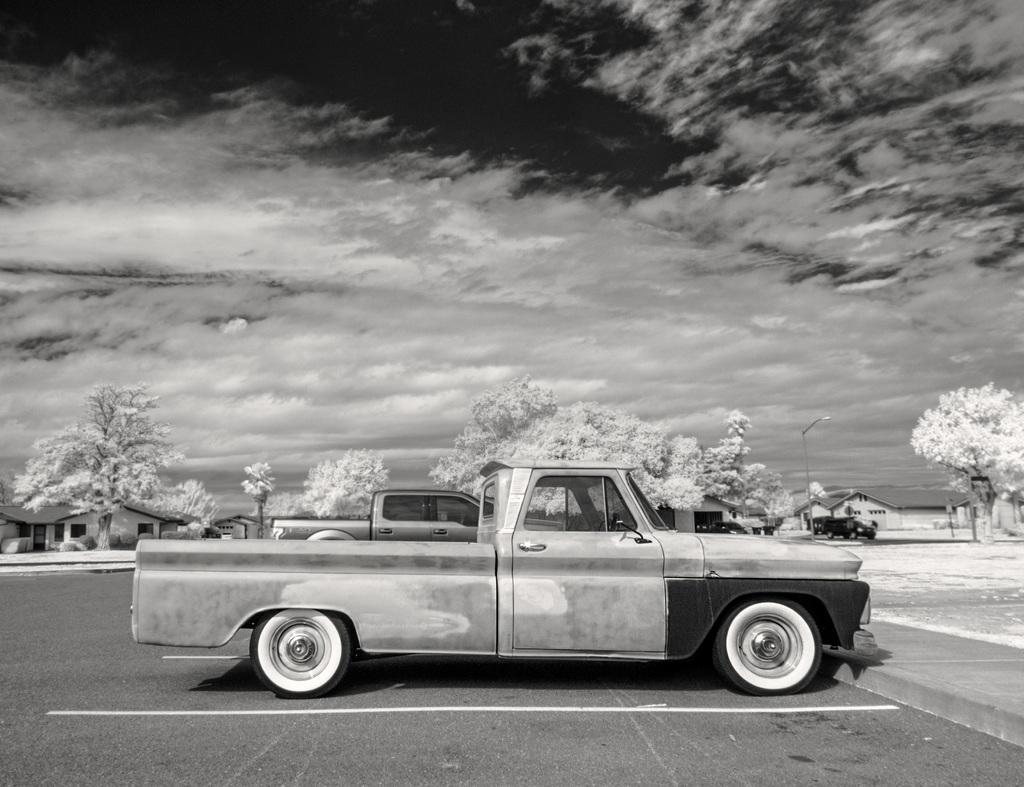In one or two sentences, can you explain what this image depicts? It looks like a black and white picture. We can see some vehicles are parked on the path. Behind the vehicles there are trees, houses, a pole with a light and behind the trees there is a cloudy sky. 